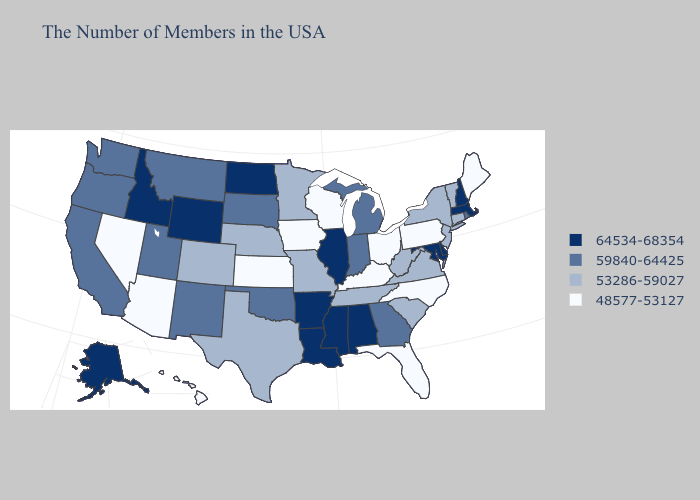Which states hav the highest value in the South?
Be succinct. Delaware, Maryland, Alabama, Mississippi, Louisiana, Arkansas. Name the states that have a value in the range 59840-64425?
Concise answer only. Rhode Island, Georgia, Michigan, Indiana, Oklahoma, South Dakota, New Mexico, Utah, Montana, California, Washington, Oregon. Does Rhode Island have the lowest value in the Northeast?
Keep it brief. No. Among the states that border Iowa , does Wisconsin have the lowest value?
Short answer required. Yes. What is the lowest value in the USA?
Short answer required. 48577-53127. Is the legend a continuous bar?
Give a very brief answer. No. What is the value of Virginia?
Short answer required. 53286-59027. Does Tennessee have a lower value than Ohio?
Keep it brief. No. Among the states that border Kansas , which have the highest value?
Quick response, please. Oklahoma. Name the states that have a value in the range 53286-59027?
Answer briefly. Vermont, Connecticut, New York, New Jersey, Virginia, South Carolina, West Virginia, Tennessee, Missouri, Minnesota, Nebraska, Texas, Colorado. What is the highest value in the MidWest ?
Quick response, please. 64534-68354. Does New Jersey have the lowest value in the USA?
Be succinct. No. Which states have the highest value in the USA?
Give a very brief answer. Massachusetts, New Hampshire, Delaware, Maryland, Alabama, Illinois, Mississippi, Louisiana, Arkansas, North Dakota, Wyoming, Idaho, Alaska. What is the value of Maryland?
Be succinct. 64534-68354. Among the states that border Indiana , which have the highest value?
Be succinct. Illinois. 